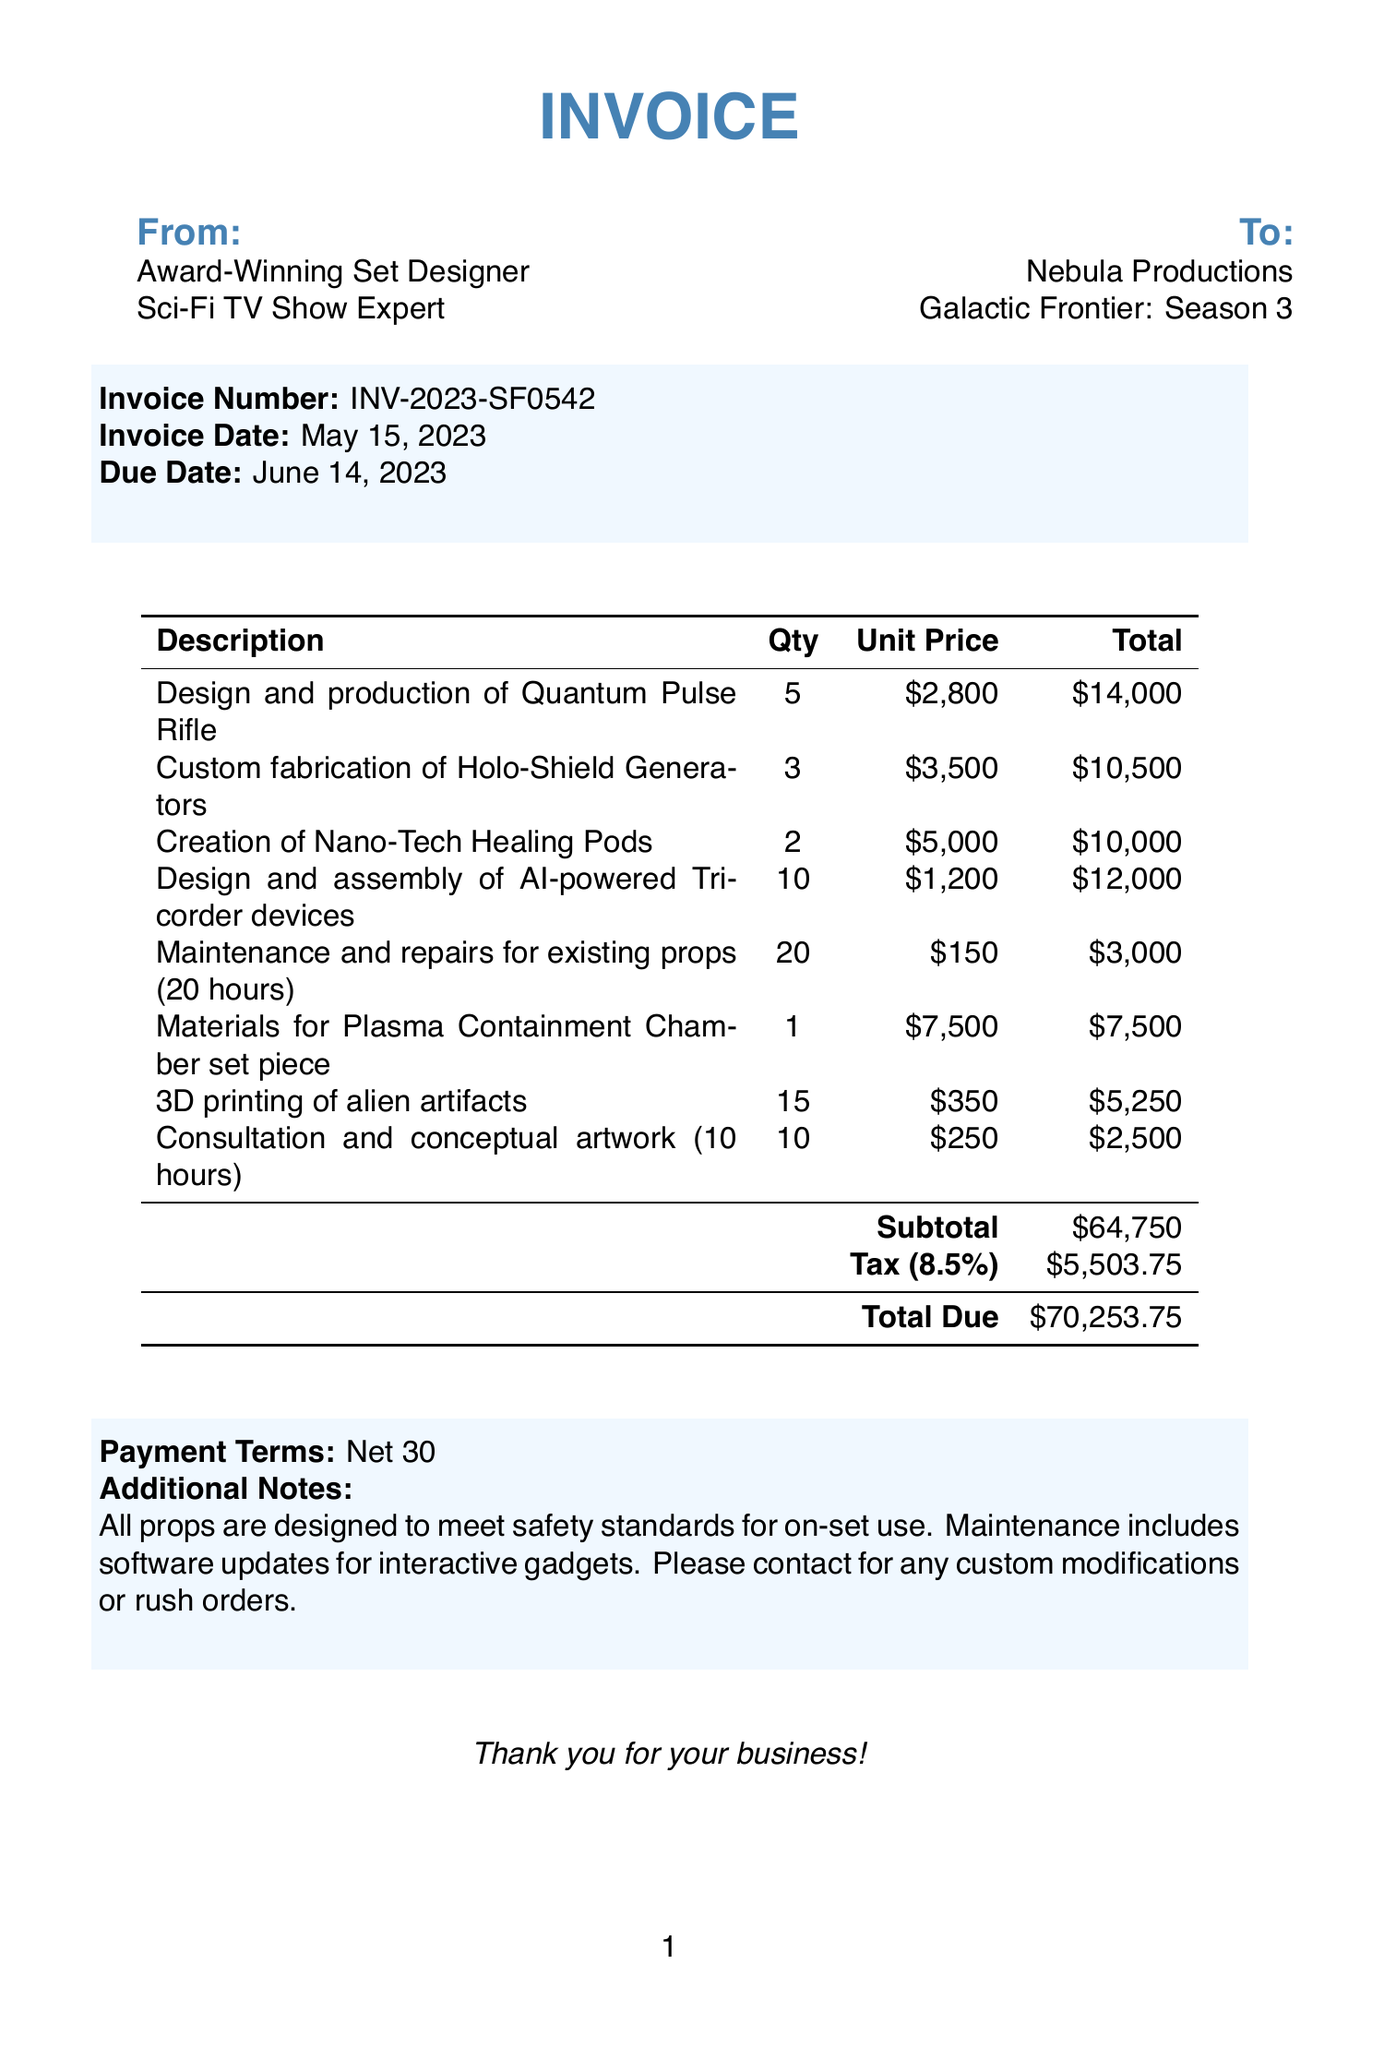What is the invoice number? The invoice number is specified in the document under the invoice details.
Answer: INV-2023-SF0542 What is the due date for the invoice? The due date is mentioned in the invoice details section for payment.
Answer: June 14, 2023 How many units of Nano-Tech Healing Pods were created? The quantity of Nano-Tech Healing Pods is listed in the items section of the invoice.
Answer: 2 What is the subtotal of the invoice? The subtotal is calculated from the total price of all items listed before tax.
Answer: $64,750 What is the tax rate applied to the invoice? The tax rate is given in the document, which is used to compute the tax amount.
Answer: 8.5% What is the total amount due? The total amount due combines the subtotal and tax amount as detailed in the invoice.
Answer: $70,253.75 How many hours were billed for maintenance and repairs? The quantity of hours for maintenance and repairs is specified directly in the items list.
Answer: 20 hours What type of payment terms are specified? The payment terms are detailed towards the end of the invoice, indicating when payment is expected.
Answer: Net 30 What type of props were designed for safety standards? Additional notes in the document highlight the design aspect of the props concerning safety.
Answer: All props 